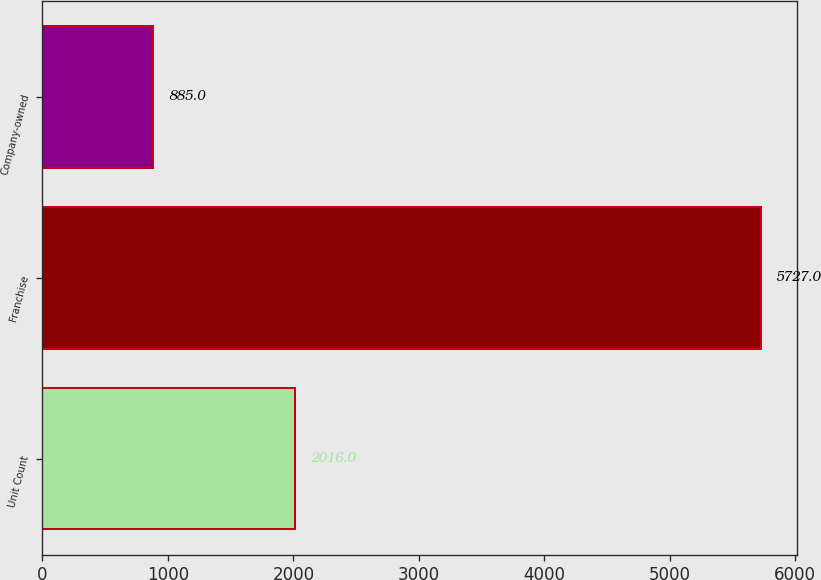<chart> <loc_0><loc_0><loc_500><loc_500><bar_chart><fcel>Unit Count<fcel>Franchise<fcel>Company-owned<nl><fcel>2016<fcel>5727<fcel>885<nl></chart> 